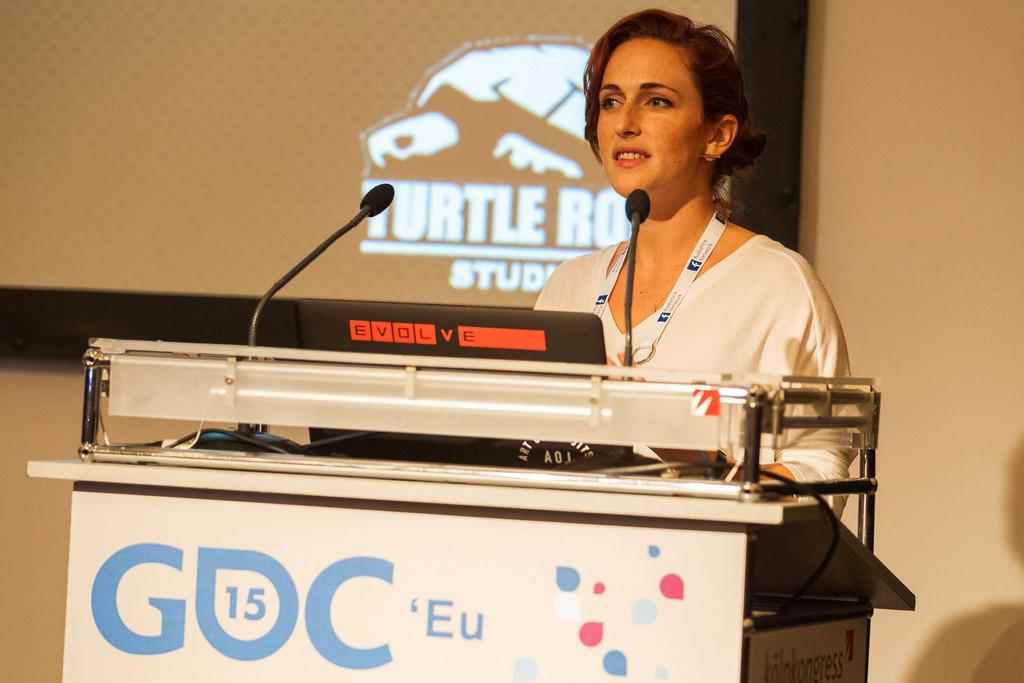What is the man in the image doing? The man is standing in front of mike's. What object can be seen in the image that is typically used for presentations? There is a podium in the image. What electronic device is visible in the image? There is a laptop in the image. What is present in the background of the image? There is a screen and a wall in the background of the image. What type of yam is being used as a prop on the podium? There is no yam present in the image; it is a podium, laptop, screen, and wall. What color is the man's underwear in the image? The man's underwear is not visible in the image, as he is fully clothed. 